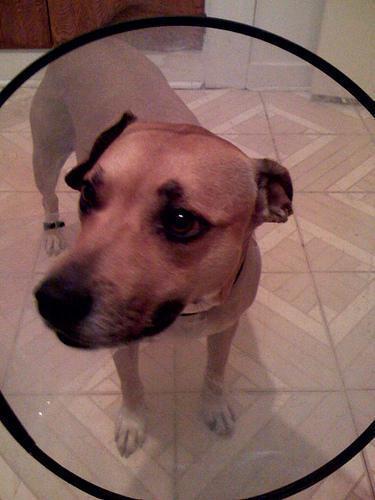How many shadows does the dog have?
Give a very brief answer. 1. 